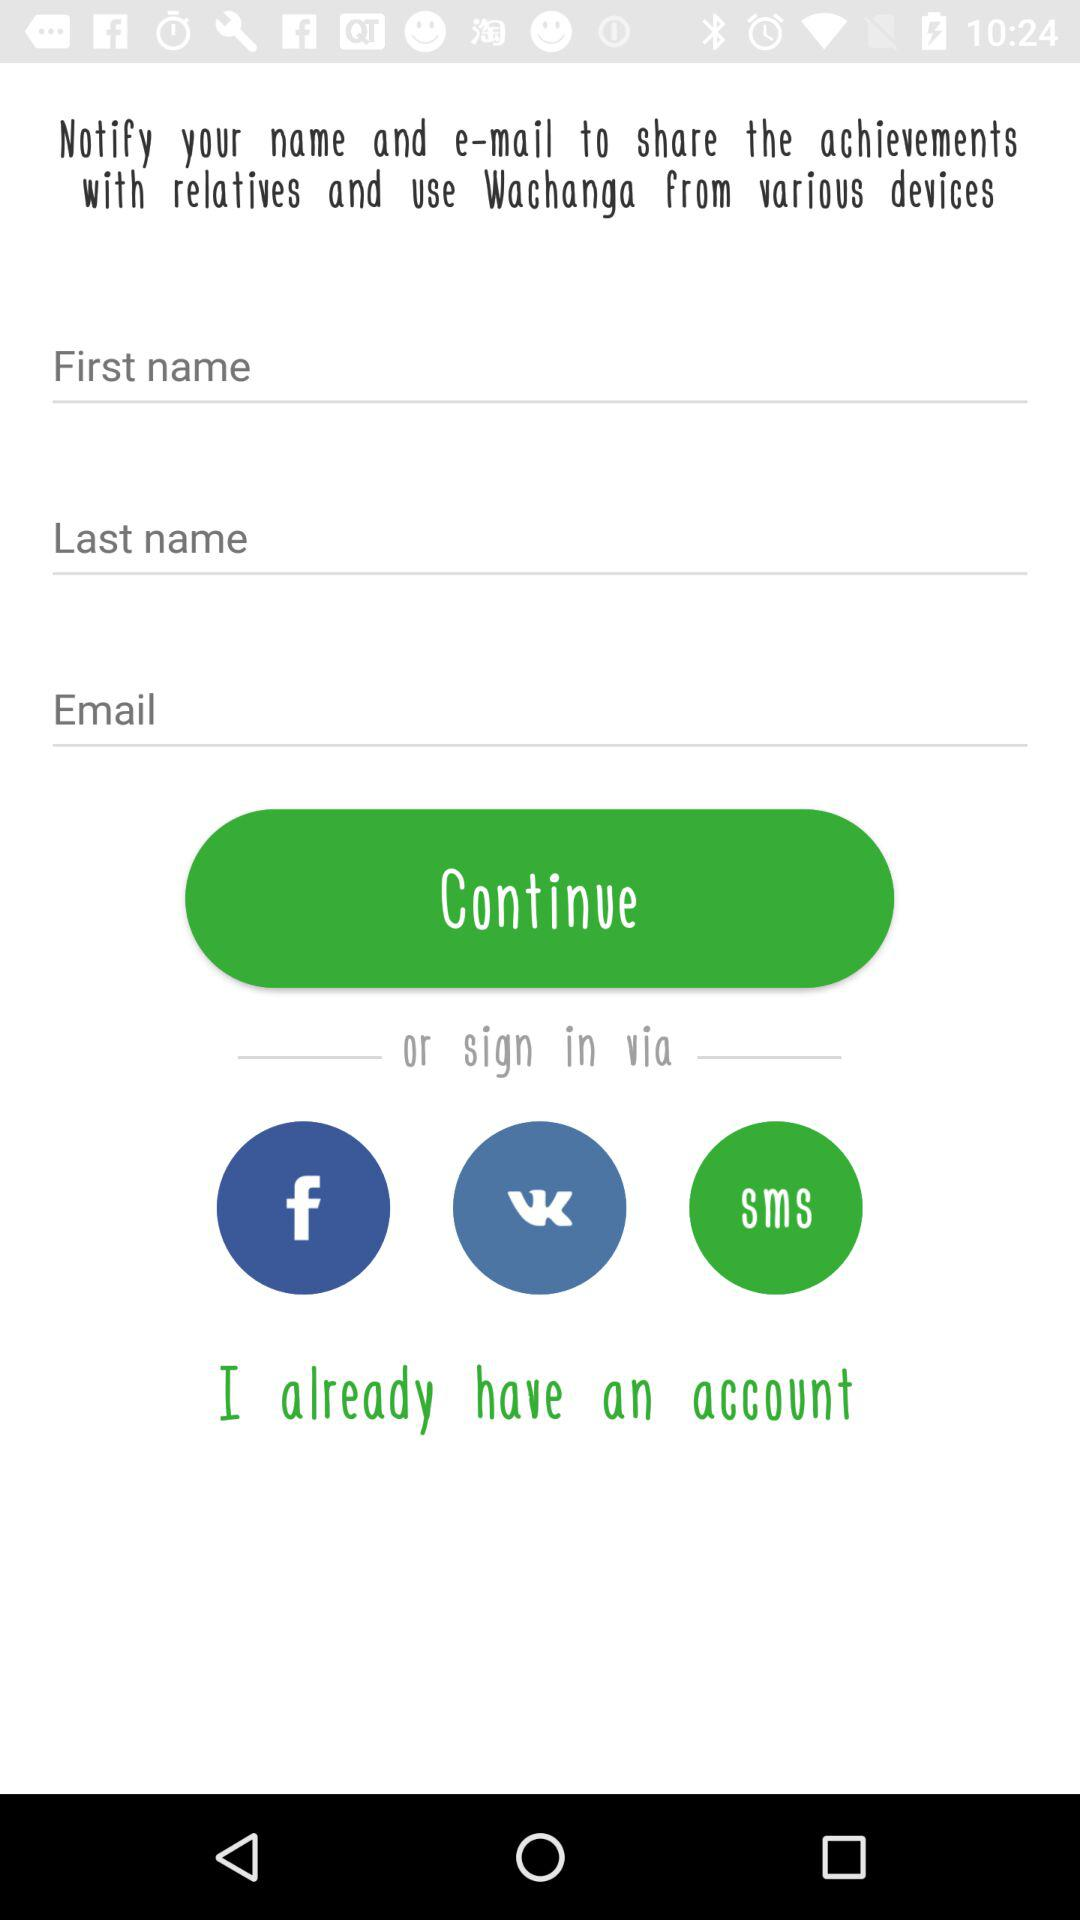Through which application can we sign in? You can sign in through "Facebook" and "VKontakte". 